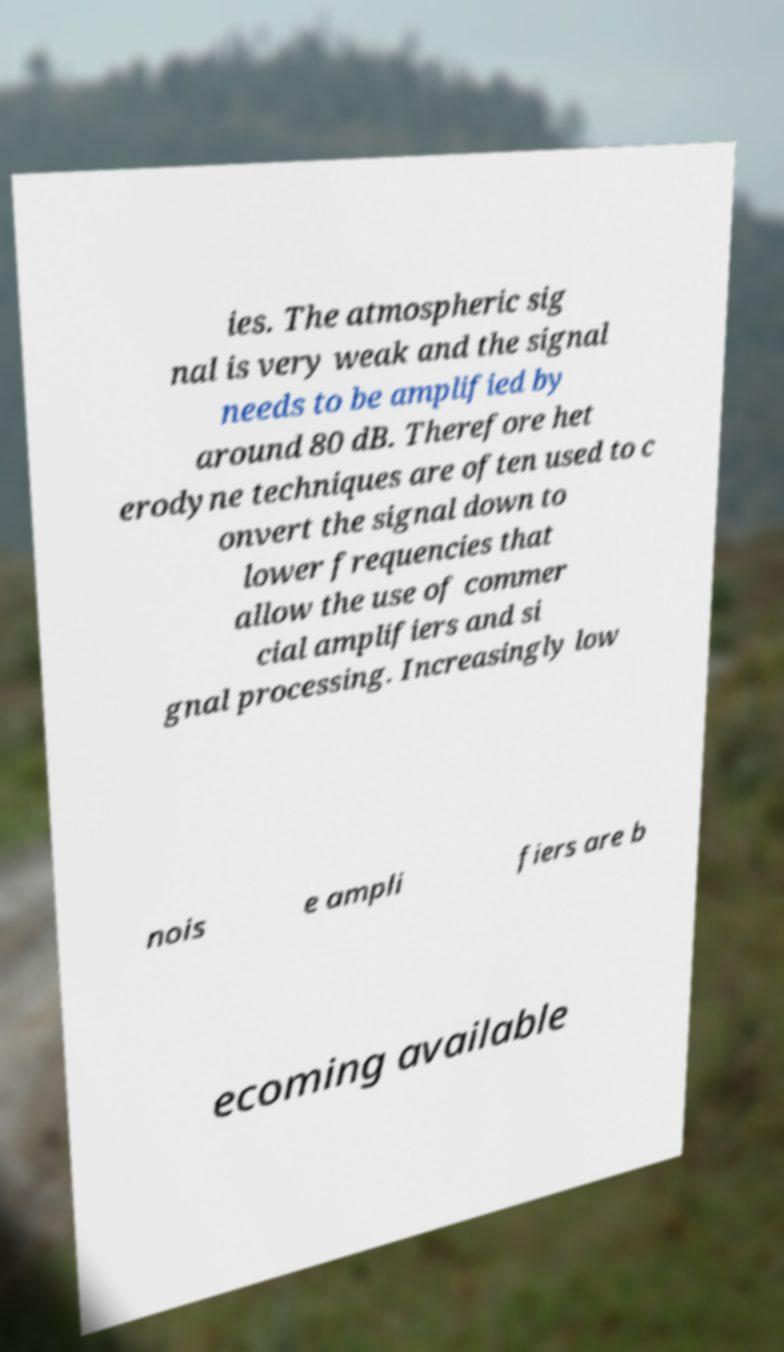There's text embedded in this image that I need extracted. Can you transcribe it verbatim? ies. The atmospheric sig nal is very weak and the signal needs to be amplified by around 80 dB. Therefore het erodyne techniques are often used to c onvert the signal down to lower frequencies that allow the use of commer cial amplifiers and si gnal processing. Increasingly low nois e ampli fiers are b ecoming available 